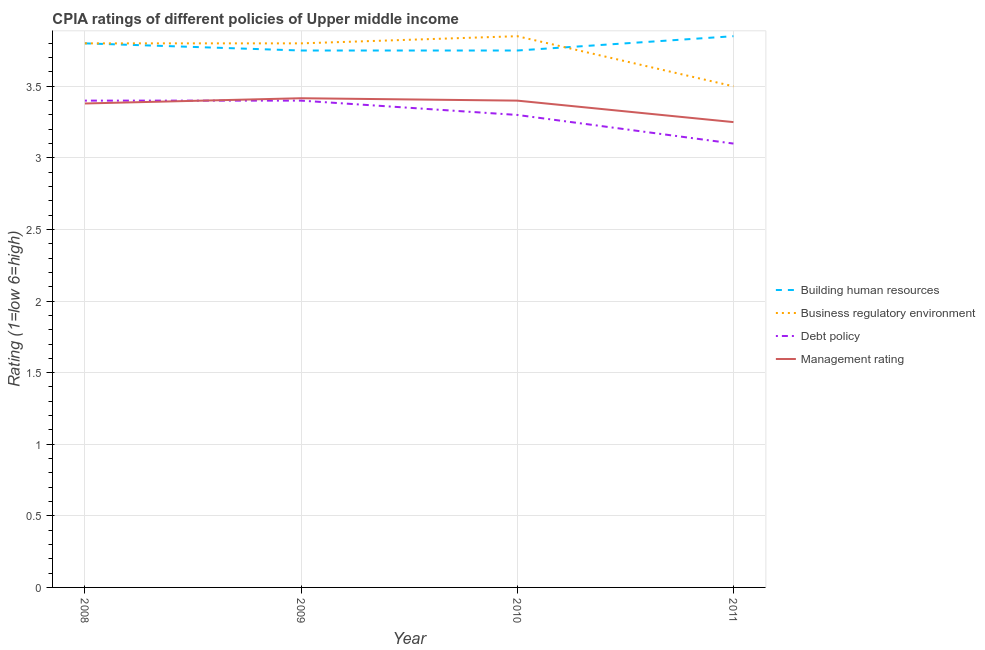How many different coloured lines are there?
Your response must be concise. 4. Does the line corresponding to cpia rating of building human resources intersect with the line corresponding to cpia rating of business regulatory environment?
Offer a terse response. Yes. What is the cpia rating of debt policy in 2009?
Offer a terse response. 3.4. Across all years, what is the maximum cpia rating of business regulatory environment?
Your response must be concise. 3.85. Across all years, what is the minimum cpia rating of building human resources?
Your response must be concise. 3.75. In which year was the cpia rating of building human resources maximum?
Keep it short and to the point. 2011. What is the total cpia rating of building human resources in the graph?
Make the answer very short. 15.15. What is the difference between the cpia rating of business regulatory environment in 2008 and that in 2011?
Ensure brevity in your answer.  0.3. What is the difference between the cpia rating of management in 2011 and the cpia rating of debt policy in 2008?
Your response must be concise. -0.15. What is the average cpia rating of building human resources per year?
Your response must be concise. 3.79. In the year 2008, what is the difference between the cpia rating of debt policy and cpia rating of business regulatory environment?
Your answer should be very brief. -0.4. What is the ratio of the cpia rating of management in 2010 to that in 2011?
Give a very brief answer. 1.05. What is the difference between the highest and the lowest cpia rating of debt policy?
Offer a very short reply. 0.3. Is it the case that in every year, the sum of the cpia rating of building human resources and cpia rating of business regulatory environment is greater than the sum of cpia rating of management and cpia rating of debt policy?
Give a very brief answer. Yes. Is the cpia rating of business regulatory environment strictly greater than the cpia rating of building human resources over the years?
Your answer should be very brief. No. How many lines are there?
Provide a short and direct response. 4. How many years are there in the graph?
Your answer should be very brief. 4. What is the difference between two consecutive major ticks on the Y-axis?
Your answer should be compact. 0.5. Are the values on the major ticks of Y-axis written in scientific E-notation?
Provide a succinct answer. No. Does the graph contain any zero values?
Give a very brief answer. No. Does the graph contain grids?
Your answer should be compact. Yes. Where does the legend appear in the graph?
Your answer should be very brief. Center right. How are the legend labels stacked?
Make the answer very short. Vertical. What is the title of the graph?
Provide a short and direct response. CPIA ratings of different policies of Upper middle income. What is the label or title of the X-axis?
Ensure brevity in your answer.  Year. What is the Rating (1=low 6=high) in Management rating in 2008?
Your answer should be very brief. 3.38. What is the Rating (1=low 6=high) in Building human resources in 2009?
Offer a very short reply. 3.75. What is the Rating (1=low 6=high) in Business regulatory environment in 2009?
Your response must be concise. 3.8. What is the Rating (1=low 6=high) of Debt policy in 2009?
Ensure brevity in your answer.  3.4. What is the Rating (1=low 6=high) of Management rating in 2009?
Your answer should be compact. 3.42. What is the Rating (1=low 6=high) of Building human resources in 2010?
Make the answer very short. 3.75. What is the Rating (1=low 6=high) in Business regulatory environment in 2010?
Offer a very short reply. 3.85. What is the Rating (1=low 6=high) of Debt policy in 2010?
Provide a short and direct response. 3.3. What is the Rating (1=low 6=high) of Management rating in 2010?
Provide a succinct answer. 3.4. What is the Rating (1=low 6=high) of Building human resources in 2011?
Provide a short and direct response. 3.85. What is the Rating (1=low 6=high) in Business regulatory environment in 2011?
Provide a short and direct response. 3.5. Across all years, what is the maximum Rating (1=low 6=high) in Building human resources?
Offer a very short reply. 3.85. Across all years, what is the maximum Rating (1=low 6=high) in Business regulatory environment?
Offer a very short reply. 3.85. Across all years, what is the maximum Rating (1=low 6=high) of Management rating?
Give a very brief answer. 3.42. Across all years, what is the minimum Rating (1=low 6=high) in Building human resources?
Offer a very short reply. 3.75. Across all years, what is the minimum Rating (1=low 6=high) of Management rating?
Your answer should be compact. 3.25. What is the total Rating (1=low 6=high) in Building human resources in the graph?
Give a very brief answer. 15.15. What is the total Rating (1=low 6=high) in Business regulatory environment in the graph?
Keep it short and to the point. 14.95. What is the total Rating (1=low 6=high) in Management rating in the graph?
Make the answer very short. 13.45. What is the difference between the Rating (1=low 6=high) of Building human resources in 2008 and that in 2009?
Your answer should be very brief. 0.05. What is the difference between the Rating (1=low 6=high) of Debt policy in 2008 and that in 2009?
Provide a short and direct response. 0. What is the difference between the Rating (1=low 6=high) in Management rating in 2008 and that in 2009?
Ensure brevity in your answer.  -0.04. What is the difference between the Rating (1=low 6=high) of Building human resources in 2008 and that in 2010?
Your answer should be compact. 0.05. What is the difference between the Rating (1=low 6=high) of Management rating in 2008 and that in 2010?
Give a very brief answer. -0.02. What is the difference between the Rating (1=low 6=high) of Management rating in 2008 and that in 2011?
Give a very brief answer. 0.13. What is the difference between the Rating (1=low 6=high) in Building human resources in 2009 and that in 2010?
Your answer should be compact. 0. What is the difference between the Rating (1=low 6=high) in Management rating in 2009 and that in 2010?
Keep it short and to the point. 0.02. What is the difference between the Rating (1=low 6=high) of Building human resources in 2009 and that in 2011?
Make the answer very short. -0.1. What is the difference between the Rating (1=low 6=high) in Business regulatory environment in 2009 and that in 2011?
Keep it short and to the point. 0.3. What is the difference between the Rating (1=low 6=high) in Debt policy in 2009 and that in 2011?
Ensure brevity in your answer.  0.3. What is the difference between the Rating (1=low 6=high) in Building human resources in 2010 and that in 2011?
Make the answer very short. -0.1. What is the difference between the Rating (1=low 6=high) in Debt policy in 2010 and that in 2011?
Your answer should be very brief. 0.2. What is the difference between the Rating (1=low 6=high) of Building human resources in 2008 and the Rating (1=low 6=high) of Management rating in 2009?
Offer a terse response. 0.38. What is the difference between the Rating (1=low 6=high) of Business regulatory environment in 2008 and the Rating (1=low 6=high) of Management rating in 2009?
Offer a very short reply. 0.38. What is the difference between the Rating (1=low 6=high) of Debt policy in 2008 and the Rating (1=low 6=high) of Management rating in 2009?
Offer a terse response. -0.02. What is the difference between the Rating (1=low 6=high) of Building human resources in 2008 and the Rating (1=low 6=high) of Business regulatory environment in 2010?
Provide a short and direct response. -0.05. What is the difference between the Rating (1=low 6=high) in Business regulatory environment in 2008 and the Rating (1=low 6=high) in Management rating in 2010?
Provide a succinct answer. 0.4. What is the difference between the Rating (1=low 6=high) in Debt policy in 2008 and the Rating (1=low 6=high) in Management rating in 2010?
Your response must be concise. 0. What is the difference between the Rating (1=low 6=high) in Building human resources in 2008 and the Rating (1=low 6=high) in Management rating in 2011?
Offer a terse response. 0.55. What is the difference between the Rating (1=low 6=high) in Business regulatory environment in 2008 and the Rating (1=low 6=high) in Debt policy in 2011?
Provide a succinct answer. 0.7. What is the difference between the Rating (1=low 6=high) in Business regulatory environment in 2008 and the Rating (1=low 6=high) in Management rating in 2011?
Your answer should be very brief. 0.55. What is the difference between the Rating (1=low 6=high) of Debt policy in 2008 and the Rating (1=low 6=high) of Management rating in 2011?
Make the answer very short. 0.15. What is the difference between the Rating (1=low 6=high) of Building human resources in 2009 and the Rating (1=low 6=high) of Business regulatory environment in 2010?
Ensure brevity in your answer.  -0.1. What is the difference between the Rating (1=low 6=high) in Building human resources in 2009 and the Rating (1=low 6=high) in Debt policy in 2010?
Make the answer very short. 0.45. What is the difference between the Rating (1=low 6=high) of Building human resources in 2009 and the Rating (1=low 6=high) of Management rating in 2010?
Provide a succinct answer. 0.35. What is the difference between the Rating (1=low 6=high) of Business regulatory environment in 2009 and the Rating (1=low 6=high) of Debt policy in 2010?
Make the answer very short. 0.5. What is the difference between the Rating (1=low 6=high) in Building human resources in 2009 and the Rating (1=low 6=high) in Debt policy in 2011?
Make the answer very short. 0.65. What is the difference between the Rating (1=low 6=high) of Business regulatory environment in 2009 and the Rating (1=low 6=high) of Debt policy in 2011?
Keep it short and to the point. 0.7. What is the difference between the Rating (1=low 6=high) in Business regulatory environment in 2009 and the Rating (1=low 6=high) in Management rating in 2011?
Give a very brief answer. 0.55. What is the difference between the Rating (1=low 6=high) of Building human resources in 2010 and the Rating (1=low 6=high) of Business regulatory environment in 2011?
Ensure brevity in your answer.  0.25. What is the difference between the Rating (1=low 6=high) of Building human resources in 2010 and the Rating (1=low 6=high) of Debt policy in 2011?
Your answer should be compact. 0.65. What is the difference between the Rating (1=low 6=high) of Business regulatory environment in 2010 and the Rating (1=low 6=high) of Debt policy in 2011?
Your answer should be compact. 0.75. What is the difference between the Rating (1=low 6=high) in Business regulatory environment in 2010 and the Rating (1=low 6=high) in Management rating in 2011?
Keep it short and to the point. 0.6. What is the average Rating (1=low 6=high) of Building human resources per year?
Your answer should be compact. 3.79. What is the average Rating (1=low 6=high) of Business regulatory environment per year?
Give a very brief answer. 3.74. What is the average Rating (1=low 6=high) of Debt policy per year?
Give a very brief answer. 3.3. What is the average Rating (1=low 6=high) of Management rating per year?
Give a very brief answer. 3.36. In the year 2008, what is the difference between the Rating (1=low 6=high) of Building human resources and Rating (1=low 6=high) of Business regulatory environment?
Make the answer very short. 0. In the year 2008, what is the difference between the Rating (1=low 6=high) of Building human resources and Rating (1=low 6=high) of Management rating?
Provide a succinct answer. 0.42. In the year 2008, what is the difference between the Rating (1=low 6=high) in Business regulatory environment and Rating (1=low 6=high) in Debt policy?
Keep it short and to the point. 0.4. In the year 2008, what is the difference between the Rating (1=low 6=high) of Business regulatory environment and Rating (1=low 6=high) of Management rating?
Your answer should be very brief. 0.42. In the year 2008, what is the difference between the Rating (1=low 6=high) in Debt policy and Rating (1=low 6=high) in Management rating?
Your response must be concise. 0.02. In the year 2009, what is the difference between the Rating (1=low 6=high) of Building human resources and Rating (1=low 6=high) of Business regulatory environment?
Your answer should be compact. -0.05. In the year 2009, what is the difference between the Rating (1=low 6=high) of Building human resources and Rating (1=low 6=high) of Debt policy?
Your response must be concise. 0.35. In the year 2009, what is the difference between the Rating (1=low 6=high) in Business regulatory environment and Rating (1=low 6=high) in Management rating?
Give a very brief answer. 0.38. In the year 2009, what is the difference between the Rating (1=low 6=high) in Debt policy and Rating (1=low 6=high) in Management rating?
Your answer should be very brief. -0.02. In the year 2010, what is the difference between the Rating (1=low 6=high) of Building human resources and Rating (1=low 6=high) of Business regulatory environment?
Offer a terse response. -0.1. In the year 2010, what is the difference between the Rating (1=low 6=high) in Building human resources and Rating (1=low 6=high) in Debt policy?
Provide a short and direct response. 0.45. In the year 2010, what is the difference between the Rating (1=low 6=high) in Building human resources and Rating (1=low 6=high) in Management rating?
Keep it short and to the point. 0.35. In the year 2010, what is the difference between the Rating (1=low 6=high) of Business regulatory environment and Rating (1=low 6=high) of Debt policy?
Keep it short and to the point. 0.55. In the year 2010, what is the difference between the Rating (1=low 6=high) of Business regulatory environment and Rating (1=low 6=high) of Management rating?
Your answer should be compact. 0.45. In the year 2011, what is the difference between the Rating (1=low 6=high) of Building human resources and Rating (1=low 6=high) of Debt policy?
Offer a terse response. 0.75. In the year 2011, what is the difference between the Rating (1=low 6=high) of Building human resources and Rating (1=low 6=high) of Management rating?
Give a very brief answer. 0.6. In the year 2011, what is the difference between the Rating (1=low 6=high) in Business regulatory environment and Rating (1=low 6=high) in Debt policy?
Provide a succinct answer. 0.4. What is the ratio of the Rating (1=low 6=high) of Building human resources in 2008 to that in 2009?
Give a very brief answer. 1.01. What is the ratio of the Rating (1=low 6=high) in Business regulatory environment in 2008 to that in 2009?
Keep it short and to the point. 1. What is the ratio of the Rating (1=low 6=high) of Management rating in 2008 to that in 2009?
Make the answer very short. 0.99. What is the ratio of the Rating (1=low 6=high) in Building human resources in 2008 to that in 2010?
Make the answer very short. 1.01. What is the ratio of the Rating (1=low 6=high) of Debt policy in 2008 to that in 2010?
Keep it short and to the point. 1.03. What is the ratio of the Rating (1=low 6=high) in Business regulatory environment in 2008 to that in 2011?
Provide a succinct answer. 1.09. What is the ratio of the Rating (1=low 6=high) in Debt policy in 2008 to that in 2011?
Your answer should be very brief. 1.1. What is the ratio of the Rating (1=low 6=high) in Management rating in 2008 to that in 2011?
Keep it short and to the point. 1.04. What is the ratio of the Rating (1=low 6=high) of Building human resources in 2009 to that in 2010?
Make the answer very short. 1. What is the ratio of the Rating (1=low 6=high) of Business regulatory environment in 2009 to that in 2010?
Provide a succinct answer. 0.99. What is the ratio of the Rating (1=low 6=high) of Debt policy in 2009 to that in 2010?
Make the answer very short. 1.03. What is the ratio of the Rating (1=low 6=high) in Management rating in 2009 to that in 2010?
Offer a terse response. 1. What is the ratio of the Rating (1=low 6=high) in Business regulatory environment in 2009 to that in 2011?
Offer a terse response. 1.09. What is the ratio of the Rating (1=low 6=high) in Debt policy in 2009 to that in 2011?
Provide a succinct answer. 1.1. What is the ratio of the Rating (1=low 6=high) of Management rating in 2009 to that in 2011?
Provide a short and direct response. 1.05. What is the ratio of the Rating (1=low 6=high) of Business regulatory environment in 2010 to that in 2011?
Offer a very short reply. 1.1. What is the ratio of the Rating (1=low 6=high) of Debt policy in 2010 to that in 2011?
Make the answer very short. 1.06. What is the ratio of the Rating (1=low 6=high) of Management rating in 2010 to that in 2011?
Your response must be concise. 1.05. What is the difference between the highest and the second highest Rating (1=low 6=high) in Building human resources?
Offer a very short reply. 0.05. What is the difference between the highest and the second highest Rating (1=low 6=high) of Business regulatory environment?
Offer a terse response. 0.05. What is the difference between the highest and the second highest Rating (1=low 6=high) of Management rating?
Make the answer very short. 0.02. What is the difference between the highest and the lowest Rating (1=low 6=high) in Business regulatory environment?
Offer a very short reply. 0.35. What is the difference between the highest and the lowest Rating (1=low 6=high) of Debt policy?
Your answer should be compact. 0.3. 